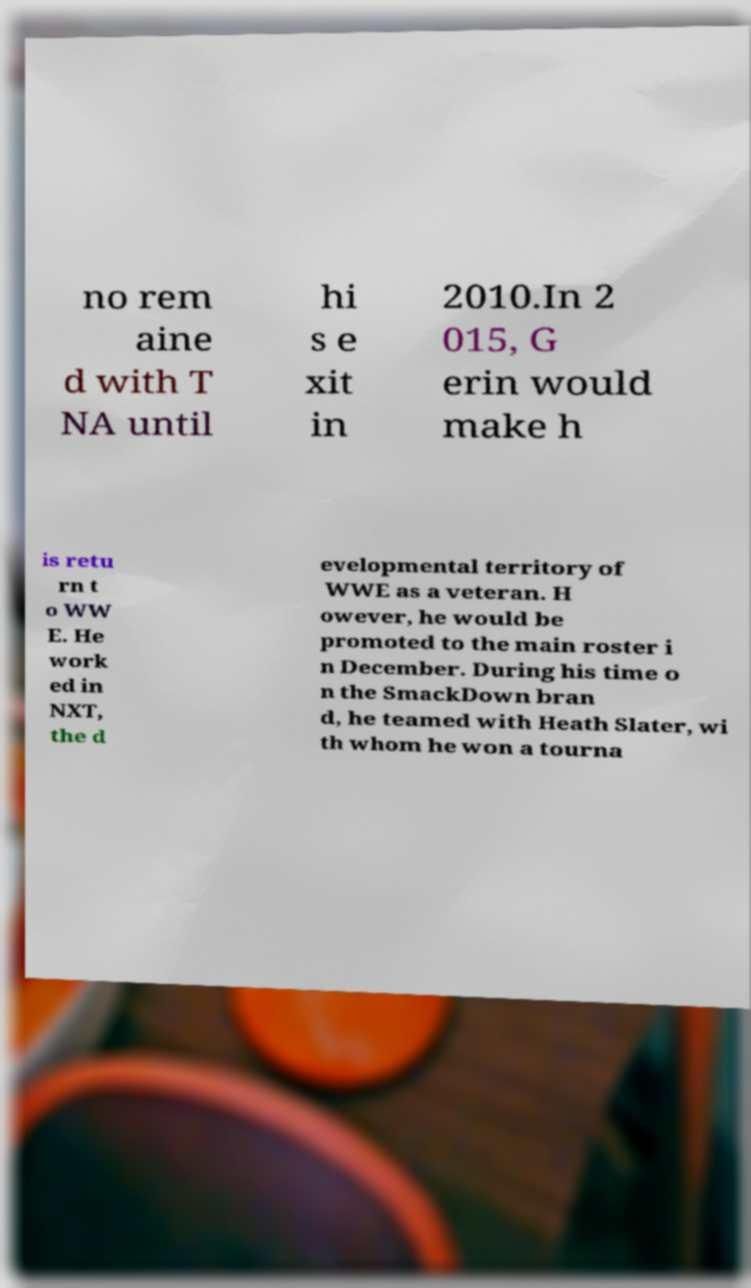Please read and relay the text visible in this image. What does it say? no rem aine d with T NA until hi s e xit in 2010.In 2 015, G erin would make h is retu rn t o WW E. He work ed in NXT, the d evelopmental territory of WWE as a veteran. H owever, he would be promoted to the main roster i n December. During his time o n the SmackDown bran d, he teamed with Heath Slater, wi th whom he won a tourna 